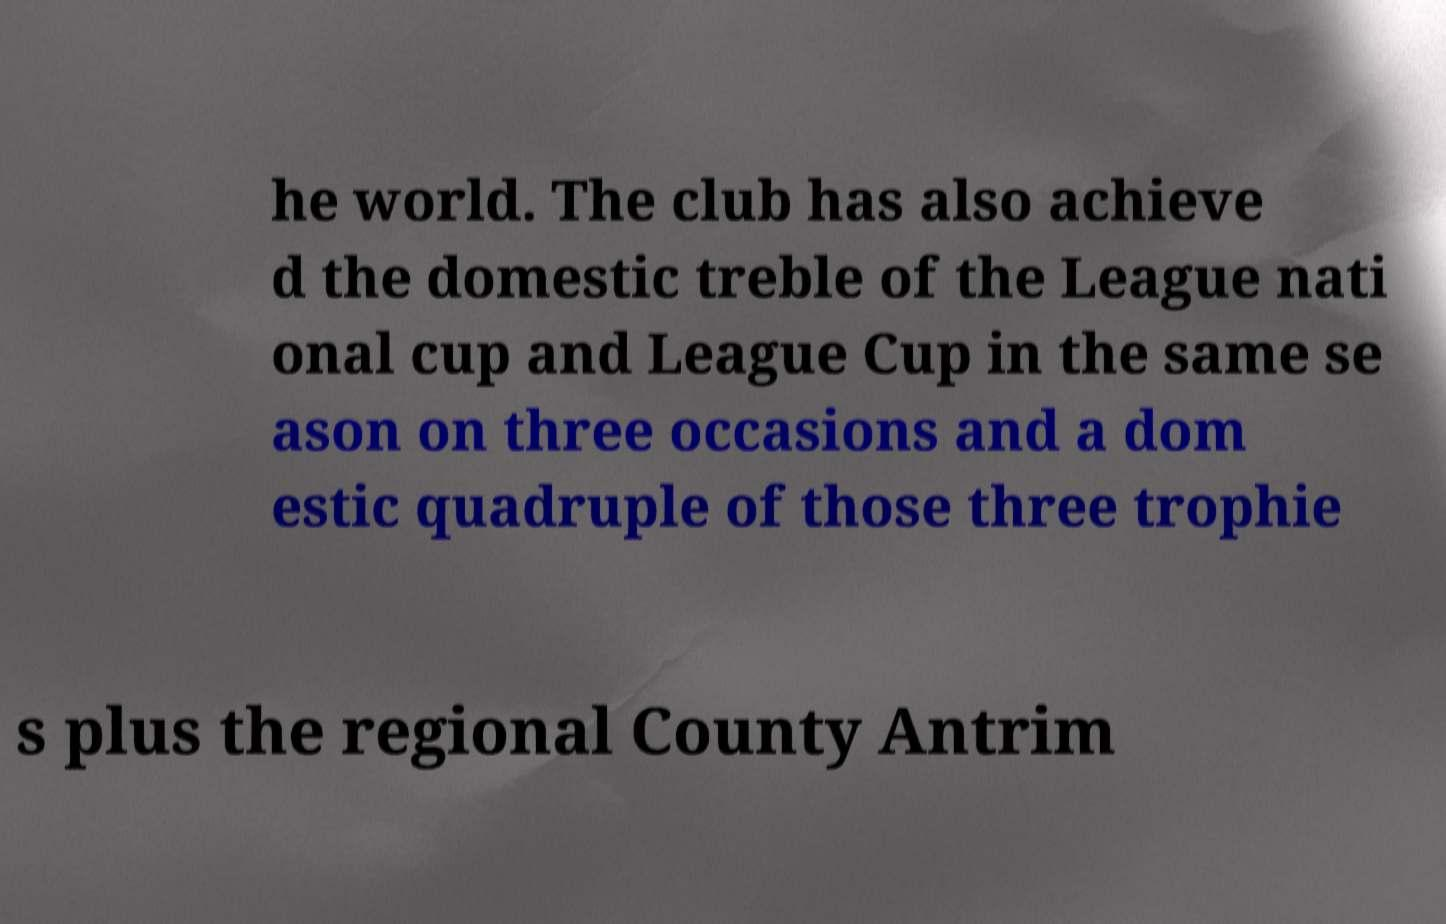Please identify and transcribe the text found in this image. he world. The club has also achieve d the domestic treble of the League nati onal cup and League Cup in the same se ason on three occasions and a dom estic quadruple of those three trophie s plus the regional County Antrim 